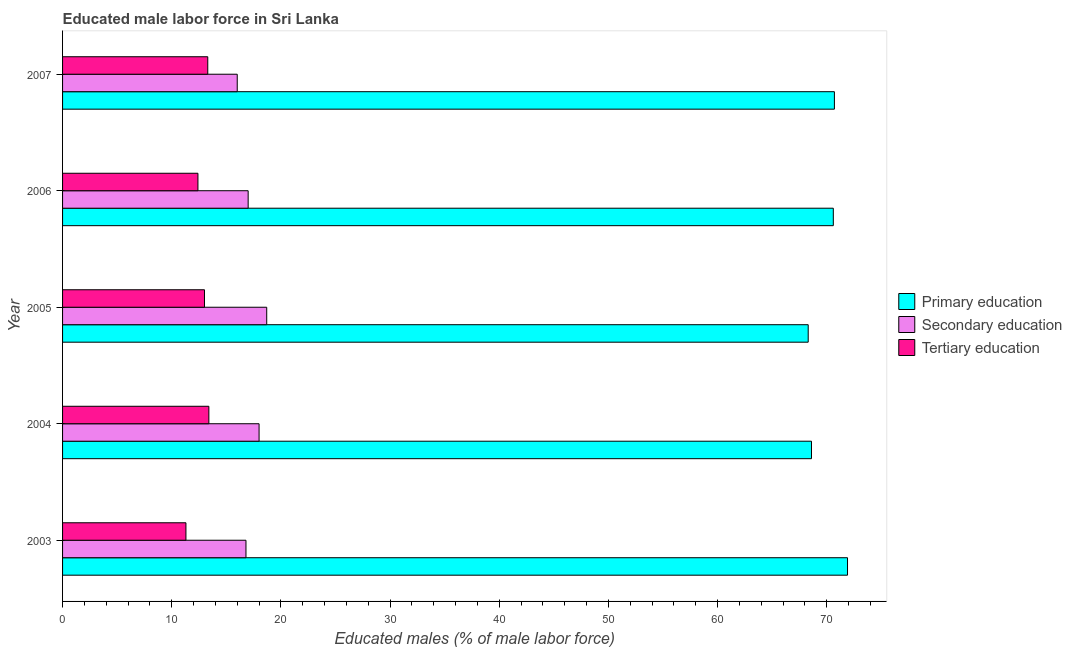How many different coloured bars are there?
Offer a very short reply. 3. Are the number of bars per tick equal to the number of legend labels?
Keep it short and to the point. Yes. Are the number of bars on each tick of the Y-axis equal?
Give a very brief answer. Yes. How many bars are there on the 5th tick from the top?
Offer a very short reply. 3. How many bars are there on the 3rd tick from the bottom?
Provide a succinct answer. 3. What is the label of the 2nd group of bars from the top?
Provide a succinct answer. 2006. What is the percentage of male labor force who received primary education in 2003?
Ensure brevity in your answer.  71.9. Across all years, what is the maximum percentage of male labor force who received primary education?
Offer a very short reply. 71.9. Across all years, what is the minimum percentage of male labor force who received primary education?
Ensure brevity in your answer.  68.3. In which year was the percentage of male labor force who received tertiary education maximum?
Give a very brief answer. 2004. What is the total percentage of male labor force who received tertiary education in the graph?
Give a very brief answer. 63.4. What is the average percentage of male labor force who received secondary education per year?
Your answer should be very brief. 17.3. In the year 2007, what is the difference between the percentage of male labor force who received primary education and percentage of male labor force who received tertiary education?
Provide a short and direct response. 57.4. What is the ratio of the percentage of male labor force who received tertiary education in 2003 to that in 2004?
Your answer should be compact. 0.84. Is the difference between the percentage of male labor force who received primary education in 2005 and 2007 greater than the difference between the percentage of male labor force who received secondary education in 2005 and 2007?
Give a very brief answer. No. In how many years, is the percentage of male labor force who received tertiary education greater than the average percentage of male labor force who received tertiary education taken over all years?
Offer a very short reply. 3. What does the 3rd bar from the top in 2006 represents?
Your answer should be very brief. Primary education. What does the 2nd bar from the bottom in 2007 represents?
Offer a terse response. Secondary education. Is it the case that in every year, the sum of the percentage of male labor force who received primary education and percentage of male labor force who received secondary education is greater than the percentage of male labor force who received tertiary education?
Offer a very short reply. Yes. Are all the bars in the graph horizontal?
Provide a short and direct response. Yes. How many years are there in the graph?
Ensure brevity in your answer.  5. What is the difference between two consecutive major ticks on the X-axis?
Offer a terse response. 10. Where does the legend appear in the graph?
Your response must be concise. Center right. How many legend labels are there?
Your response must be concise. 3. What is the title of the graph?
Give a very brief answer. Educated male labor force in Sri Lanka. What is the label or title of the X-axis?
Offer a terse response. Educated males (% of male labor force). What is the Educated males (% of male labor force) of Primary education in 2003?
Your response must be concise. 71.9. What is the Educated males (% of male labor force) of Secondary education in 2003?
Provide a short and direct response. 16.8. What is the Educated males (% of male labor force) in Tertiary education in 2003?
Offer a terse response. 11.3. What is the Educated males (% of male labor force) in Primary education in 2004?
Keep it short and to the point. 68.6. What is the Educated males (% of male labor force) in Secondary education in 2004?
Keep it short and to the point. 18. What is the Educated males (% of male labor force) of Tertiary education in 2004?
Give a very brief answer. 13.4. What is the Educated males (% of male labor force) of Primary education in 2005?
Your answer should be compact. 68.3. What is the Educated males (% of male labor force) of Secondary education in 2005?
Your response must be concise. 18.7. What is the Educated males (% of male labor force) in Tertiary education in 2005?
Your response must be concise. 13. What is the Educated males (% of male labor force) of Primary education in 2006?
Provide a succinct answer. 70.6. What is the Educated males (% of male labor force) in Tertiary education in 2006?
Offer a terse response. 12.4. What is the Educated males (% of male labor force) in Primary education in 2007?
Ensure brevity in your answer.  70.7. What is the Educated males (% of male labor force) of Secondary education in 2007?
Ensure brevity in your answer.  16. What is the Educated males (% of male labor force) of Tertiary education in 2007?
Keep it short and to the point. 13.3. Across all years, what is the maximum Educated males (% of male labor force) in Primary education?
Offer a terse response. 71.9. Across all years, what is the maximum Educated males (% of male labor force) of Secondary education?
Your answer should be compact. 18.7. Across all years, what is the maximum Educated males (% of male labor force) of Tertiary education?
Provide a succinct answer. 13.4. Across all years, what is the minimum Educated males (% of male labor force) in Primary education?
Offer a very short reply. 68.3. Across all years, what is the minimum Educated males (% of male labor force) in Secondary education?
Offer a very short reply. 16. Across all years, what is the minimum Educated males (% of male labor force) of Tertiary education?
Give a very brief answer. 11.3. What is the total Educated males (% of male labor force) in Primary education in the graph?
Ensure brevity in your answer.  350.1. What is the total Educated males (% of male labor force) in Secondary education in the graph?
Your response must be concise. 86.5. What is the total Educated males (% of male labor force) in Tertiary education in the graph?
Your answer should be compact. 63.4. What is the difference between the Educated males (% of male labor force) of Primary education in 2003 and that in 2004?
Your answer should be compact. 3.3. What is the difference between the Educated males (% of male labor force) of Tertiary education in 2003 and that in 2004?
Offer a terse response. -2.1. What is the difference between the Educated males (% of male labor force) in Primary education in 2003 and that in 2006?
Your response must be concise. 1.3. What is the difference between the Educated males (% of male labor force) of Secondary education in 2003 and that in 2006?
Keep it short and to the point. -0.2. What is the difference between the Educated males (% of male labor force) in Tertiary education in 2003 and that in 2006?
Ensure brevity in your answer.  -1.1. What is the difference between the Educated males (% of male labor force) in Primary education in 2003 and that in 2007?
Make the answer very short. 1.2. What is the difference between the Educated males (% of male labor force) of Secondary education in 2003 and that in 2007?
Ensure brevity in your answer.  0.8. What is the difference between the Educated males (% of male labor force) in Primary education in 2004 and that in 2006?
Offer a terse response. -2. What is the difference between the Educated males (% of male labor force) in Secondary education in 2004 and that in 2006?
Your answer should be compact. 1. What is the difference between the Educated males (% of male labor force) in Primary education in 2004 and that in 2007?
Offer a terse response. -2.1. What is the difference between the Educated males (% of male labor force) of Secondary education in 2004 and that in 2007?
Give a very brief answer. 2. What is the difference between the Educated males (% of male labor force) in Secondary education in 2005 and that in 2006?
Your response must be concise. 1.7. What is the difference between the Educated males (% of male labor force) in Tertiary education in 2005 and that in 2007?
Offer a very short reply. -0.3. What is the difference between the Educated males (% of male labor force) of Primary education in 2006 and that in 2007?
Your response must be concise. -0.1. What is the difference between the Educated males (% of male labor force) in Secondary education in 2006 and that in 2007?
Provide a short and direct response. 1. What is the difference between the Educated males (% of male labor force) in Primary education in 2003 and the Educated males (% of male labor force) in Secondary education in 2004?
Your answer should be compact. 53.9. What is the difference between the Educated males (% of male labor force) of Primary education in 2003 and the Educated males (% of male labor force) of Tertiary education in 2004?
Your answer should be compact. 58.5. What is the difference between the Educated males (% of male labor force) of Secondary education in 2003 and the Educated males (% of male labor force) of Tertiary education in 2004?
Keep it short and to the point. 3.4. What is the difference between the Educated males (% of male labor force) in Primary education in 2003 and the Educated males (% of male labor force) in Secondary education in 2005?
Your answer should be compact. 53.2. What is the difference between the Educated males (% of male labor force) in Primary education in 2003 and the Educated males (% of male labor force) in Tertiary education in 2005?
Offer a very short reply. 58.9. What is the difference between the Educated males (% of male labor force) in Secondary education in 2003 and the Educated males (% of male labor force) in Tertiary education in 2005?
Your answer should be compact. 3.8. What is the difference between the Educated males (% of male labor force) in Primary education in 2003 and the Educated males (% of male labor force) in Secondary education in 2006?
Your response must be concise. 54.9. What is the difference between the Educated males (% of male labor force) in Primary education in 2003 and the Educated males (% of male labor force) in Tertiary education in 2006?
Your answer should be very brief. 59.5. What is the difference between the Educated males (% of male labor force) in Primary education in 2003 and the Educated males (% of male labor force) in Secondary education in 2007?
Make the answer very short. 55.9. What is the difference between the Educated males (% of male labor force) in Primary education in 2003 and the Educated males (% of male labor force) in Tertiary education in 2007?
Provide a short and direct response. 58.6. What is the difference between the Educated males (% of male labor force) of Primary education in 2004 and the Educated males (% of male labor force) of Secondary education in 2005?
Give a very brief answer. 49.9. What is the difference between the Educated males (% of male labor force) in Primary education in 2004 and the Educated males (% of male labor force) in Tertiary education in 2005?
Your response must be concise. 55.6. What is the difference between the Educated males (% of male labor force) in Secondary education in 2004 and the Educated males (% of male labor force) in Tertiary education in 2005?
Keep it short and to the point. 5. What is the difference between the Educated males (% of male labor force) of Primary education in 2004 and the Educated males (% of male labor force) of Secondary education in 2006?
Your answer should be compact. 51.6. What is the difference between the Educated males (% of male labor force) in Primary education in 2004 and the Educated males (% of male labor force) in Tertiary education in 2006?
Keep it short and to the point. 56.2. What is the difference between the Educated males (% of male labor force) of Primary education in 2004 and the Educated males (% of male labor force) of Secondary education in 2007?
Offer a terse response. 52.6. What is the difference between the Educated males (% of male labor force) of Primary education in 2004 and the Educated males (% of male labor force) of Tertiary education in 2007?
Your response must be concise. 55.3. What is the difference between the Educated males (% of male labor force) in Secondary education in 2004 and the Educated males (% of male labor force) in Tertiary education in 2007?
Offer a very short reply. 4.7. What is the difference between the Educated males (% of male labor force) of Primary education in 2005 and the Educated males (% of male labor force) of Secondary education in 2006?
Offer a terse response. 51.3. What is the difference between the Educated males (% of male labor force) in Primary education in 2005 and the Educated males (% of male labor force) in Tertiary education in 2006?
Give a very brief answer. 55.9. What is the difference between the Educated males (% of male labor force) of Primary education in 2005 and the Educated males (% of male labor force) of Secondary education in 2007?
Your response must be concise. 52.3. What is the difference between the Educated males (% of male labor force) of Primary education in 2005 and the Educated males (% of male labor force) of Tertiary education in 2007?
Provide a short and direct response. 55. What is the difference between the Educated males (% of male labor force) in Secondary education in 2005 and the Educated males (% of male labor force) in Tertiary education in 2007?
Your response must be concise. 5.4. What is the difference between the Educated males (% of male labor force) of Primary education in 2006 and the Educated males (% of male labor force) of Secondary education in 2007?
Provide a short and direct response. 54.6. What is the difference between the Educated males (% of male labor force) of Primary education in 2006 and the Educated males (% of male labor force) of Tertiary education in 2007?
Your answer should be compact. 57.3. What is the difference between the Educated males (% of male labor force) in Secondary education in 2006 and the Educated males (% of male labor force) in Tertiary education in 2007?
Make the answer very short. 3.7. What is the average Educated males (% of male labor force) in Primary education per year?
Make the answer very short. 70.02. What is the average Educated males (% of male labor force) in Tertiary education per year?
Keep it short and to the point. 12.68. In the year 2003, what is the difference between the Educated males (% of male labor force) in Primary education and Educated males (% of male labor force) in Secondary education?
Offer a very short reply. 55.1. In the year 2003, what is the difference between the Educated males (% of male labor force) of Primary education and Educated males (% of male labor force) of Tertiary education?
Offer a very short reply. 60.6. In the year 2004, what is the difference between the Educated males (% of male labor force) in Primary education and Educated males (% of male labor force) in Secondary education?
Provide a succinct answer. 50.6. In the year 2004, what is the difference between the Educated males (% of male labor force) in Primary education and Educated males (% of male labor force) in Tertiary education?
Offer a terse response. 55.2. In the year 2005, what is the difference between the Educated males (% of male labor force) in Primary education and Educated males (% of male labor force) in Secondary education?
Your answer should be compact. 49.6. In the year 2005, what is the difference between the Educated males (% of male labor force) in Primary education and Educated males (% of male labor force) in Tertiary education?
Give a very brief answer. 55.3. In the year 2006, what is the difference between the Educated males (% of male labor force) in Primary education and Educated males (% of male labor force) in Secondary education?
Your answer should be compact. 53.6. In the year 2006, what is the difference between the Educated males (% of male labor force) of Primary education and Educated males (% of male labor force) of Tertiary education?
Ensure brevity in your answer.  58.2. In the year 2007, what is the difference between the Educated males (% of male labor force) of Primary education and Educated males (% of male labor force) of Secondary education?
Provide a short and direct response. 54.7. In the year 2007, what is the difference between the Educated males (% of male labor force) in Primary education and Educated males (% of male labor force) in Tertiary education?
Your answer should be very brief. 57.4. In the year 2007, what is the difference between the Educated males (% of male labor force) of Secondary education and Educated males (% of male labor force) of Tertiary education?
Your response must be concise. 2.7. What is the ratio of the Educated males (% of male labor force) in Primary education in 2003 to that in 2004?
Your answer should be compact. 1.05. What is the ratio of the Educated males (% of male labor force) in Secondary education in 2003 to that in 2004?
Make the answer very short. 0.93. What is the ratio of the Educated males (% of male labor force) in Tertiary education in 2003 to that in 2004?
Provide a short and direct response. 0.84. What is the ratio of the Educated males (% of male labor force) in Primary education in 2003 to that in 2005?
Give a very brief answer. 1.05. What is the ratio of the Educated males (% of male labor force) of Secondary education in 2003 to that in 2005?
Provide a short and direct response. 0.9. What is the ratio of the Educated males (% of male labor force) in Tertiary education in 2003 to that in 2005?
Offer a very short reply. 0.87. What is the ratio of the Educated males (% of male labor force) in Primary education in 2003 to that in 2006?
Offer a terse response. 1.02. What is the ratio of the Educated males (% of male labor force) of Tertiary education in 2003 to that in 2006?
Keep it short and to the point. 0.91. What is the ratio of the Educated males (% of male labor force) in Primary education in 2003 to that in 2007?
Provide a succinct answer. 1.02. What is the ratio of the Educated males (% of male labor force) of Tertiary education in 2003 to that in 2007?
Make the answer very short. 0.85. What is the ratio of the Educated males (% of male labor force) of Primary education in 2004 to that in 2005?
Your response must be concise. 1. What is the ratio of the Educated males (% of male labor force) in Secondary education in 2004 to that in 2005?
Provide a succinct answer. 0.96. What is the ratio of the Educated males (% of male labor force) in Tertiary education in 2004 to that in 2005?
Offer a terse response. 1.03. What is the ratio of the Educated males (% of male labor force) of Primary education in 2004 to that in 2006?
Give a very brief answer. 0.97. What is the ratio of the Educated males (% of male labor force) in Secondary education in 2004 to that in 2006?
Your answer should be compact. 1.06. What is the ratio of the Educated males (% of male labor force) in Tertiary education in 2004 to that in 2006?
Provide a succinct answer. 1.08. What is the ratio of the Educated males (% of male labor force) of Primary education in 2004 to that in 2007?
Ensure brevity in your answer.  0.97. What is the ratio of the Educated males (% of male labor force) of Tertiary education in 2004 to that in 2007?
Keep it short and to the point. 1.01. What is the ratio of the Educated males (% of male labor force) of Primary education in 2005 to that in 2006?
Make the answer very short. 0.97. What is the ratio of the Educated males (% of male labor force) of Tertiary education in 2005 to that in 2006?
Offer a terse response. 1.05. What is the ratio of the Educated males (% of male labor force) of Primary education in 2005 to that in 2007?
Offer a very short reply. 0.97. What is the ratio of the Educated males (% of male labor force) of Secondary education in 2005 to that in 2007?
Your response must be concise. 1.17. What is the ratio of the Educated males (% of male labor force) of Tertiary education in 2005 to that in 2007?
Your answer should be compact. 0.98. What is the ratio of the Educated males (% of male labor force) of Tertiary education in 2006 to that in 2007?
Provide a short and direct response. 0.93. What is the difference between the highest and the second highest Educated males (% of male labor force) of Tertiary education?
Ensure brevity in your answer.  0.1. What is the difference between the highest and the lowest Educated males (% of male labor force) of Primary education?
Ensure brevity in your answer.  3.6. What is the difference between the highest and the lowest Educated males (% of male labor force) of Tertiary education?
Provide a succinct answer. 2.1. 